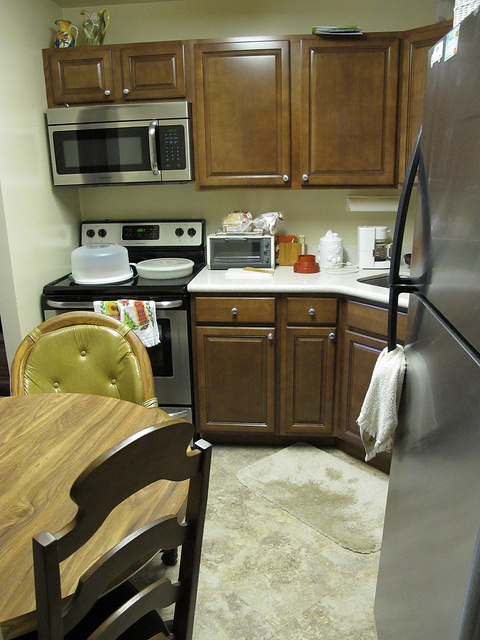Describe the objects in this image and their specific colors. I can see refrigerator in darkgray, gray, and black tones, dining table in darkgray, tan, black, and olive tones, chair in darkgray, black, tan, darkgreen, and gray tones, oven in darkgray, black, gray, and lightgray tones, and microwave in darkgray, black, gray, and darkgreen tones in this image. 